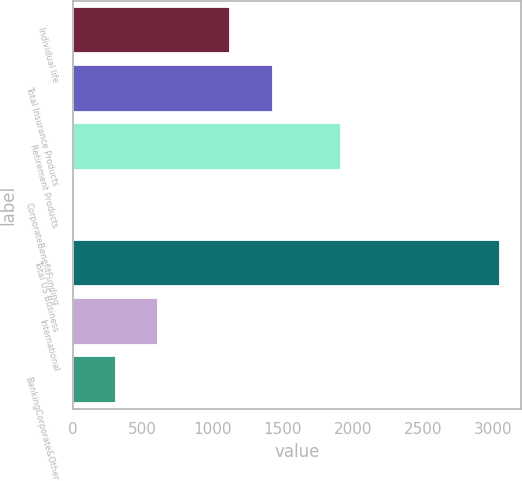<chart> <loc_0><loc_0><loc_500><loc_500><bar_chart><fcel>Individual life<fcel>Total Insurance Products<fcel>Retirement Products<fcel>CorporateBenefitFunding<fcel>Total US Business<fcel>International<fcel>BankingCorporate&Other<nl><fcel>1122<fcel>1426.6<fcel>1917<fcel>3<fcel>3049<fcel>612.2<fcel>307.6<nl></chart> 